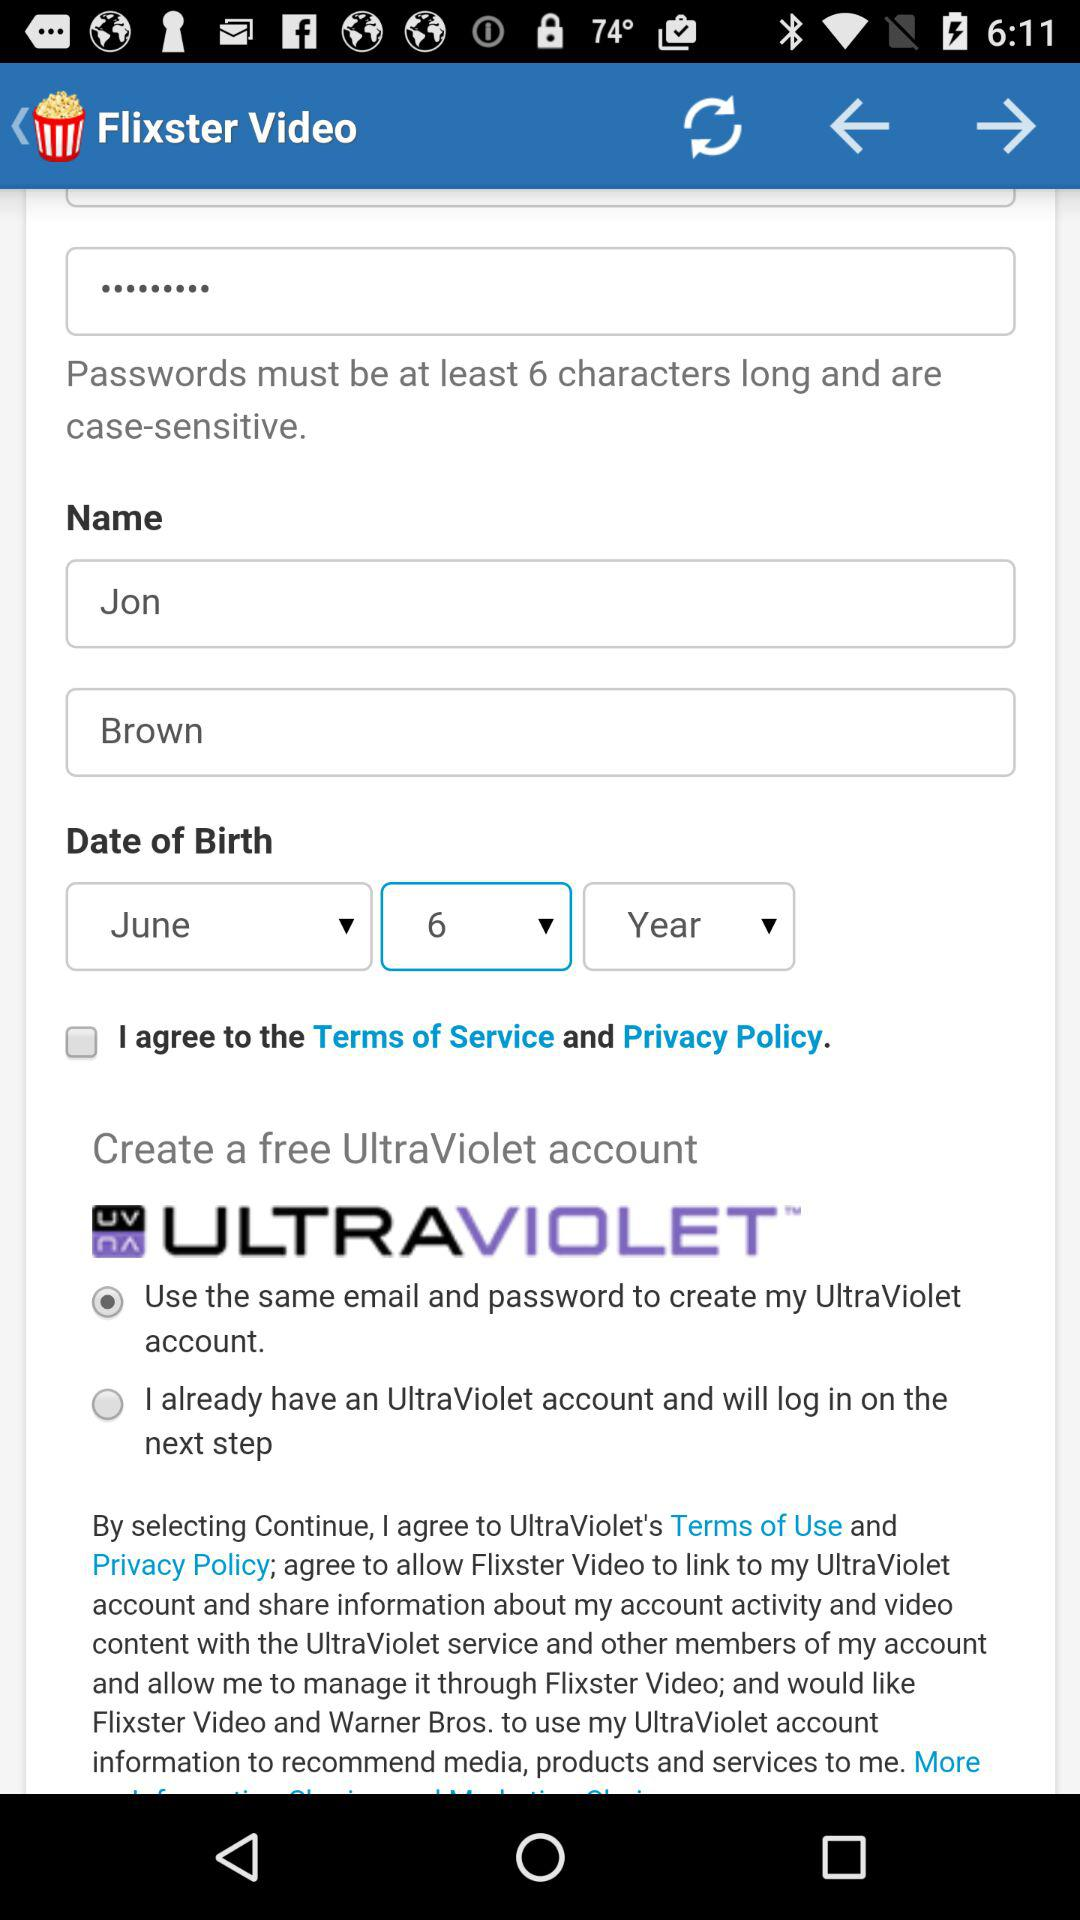What option has been selected to create a free account?
Answer the question using a single word or phrase. The selected option is: "Use the same email and password to create my UltraViolet account." 